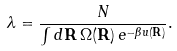Convert formula to latex. <formula><loc_0><loc_0><loc_500><loc_500>\lambda = \frac { N } { \int { d } { \mathbf R } \, \Omega ( { \mathbf R } ) \, e ^ { - \beta u ( { \mathbf R } ) } } .</formula> 